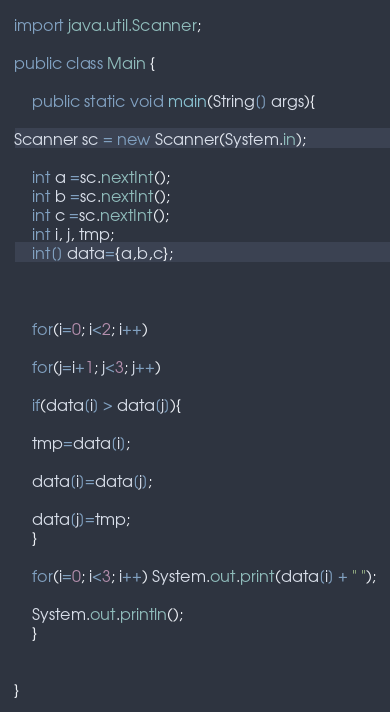Convert code to text. <code><loc_0><loc_0><loc_500><loc_500><_Java_>import java.util.Scanner;

public class Main {

	public static void main(String[] args){

Scanner sc = new Scanner(System.in);
	
	int a =sc.nextInt();
	int b =sc.nextInt();
	int c =sc.nextInt();
	int i, j, tmp;
	int[] data={a,b,c};

	

	for(i=0; i<2; i++)

	for(j=i+1; j<3; j++)

	if(data[i] > data[j]){

	tmp=data[i];

	data[i]=data[j];

	data[j]=tmp;
	}

	for(i=0; i<3; i++) System.out.print(data[i] + " ");

	System.out.println();
	}

	
}

</code> 